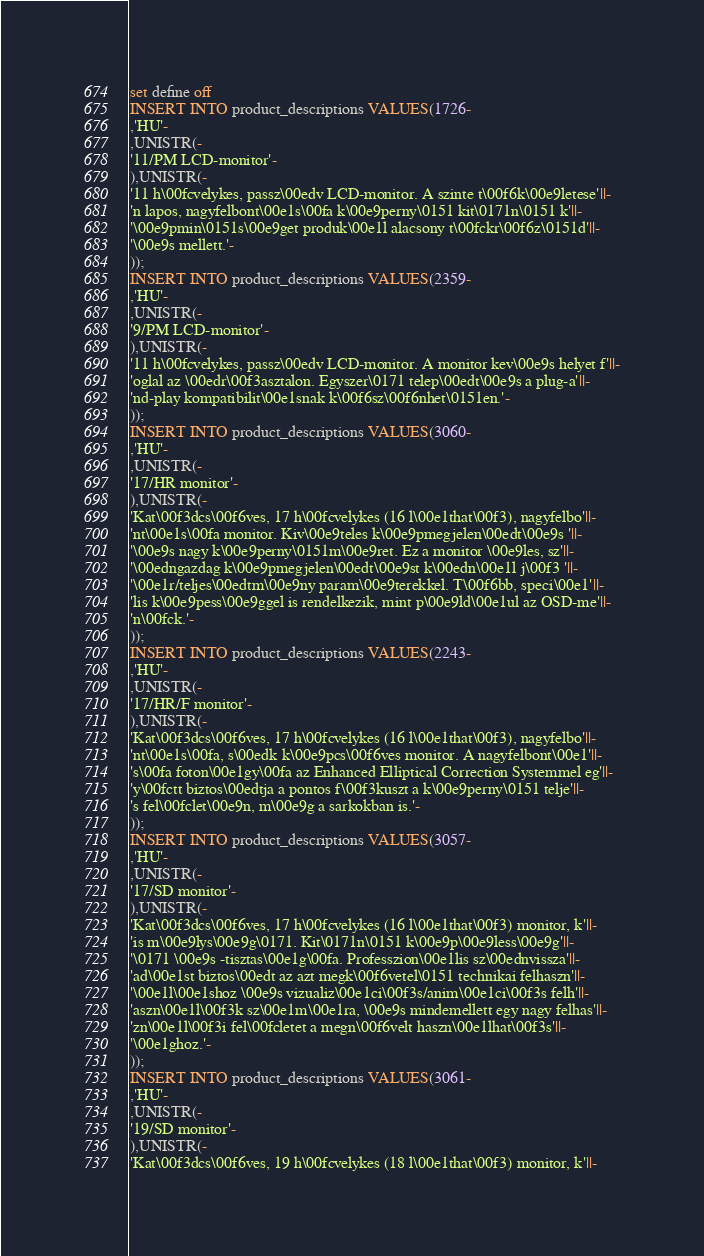<code> <loc_0><loc_0><loc_500><loc_500><_SQL_>set define off
INSERT INTO product_descriptions VALUES(1726-
,'HU'-
,UNISTR(-
'11/PM LCD-monitor'-
),UNISTR(-
'11 h\00fcvelykes, passz\00edv LCD-monitor. A szinte t\00f6k\00e9letese'||-
'n lapos, nagyfelbont\00e1s\00fa k\00e9perny\0151 kit\0171n\0151 k'||-
'\00e9pmin\0151s\00e9get produk\00e1l alacsony t\00fckr\00f6z\0151d'||-
'\00e9s mellett.'-
));
INSERT INTO product_descriptions VALUES(2359-
,'HU'-
,UNISTR(-
'9/PM LCD-monitor'-
),UNISTR(-
'11 h\00fcvelykes, passz\00edv LCD-monitor. A monitor kev\00e9s helyet f'||-
'oglal az \00edr\00f3asztalon. Egyszer\0171 telep\00edt\00e9s a plug-a'||-
'nd-play kompatibilit\00e1snak k\00f6sz\00f6nhet\0151en.'-
));
INSERT INTO product_descriptions VALUES(3060-
,'HU'-
,UNISTR(-
'17/HR monitor'-
),UNISTR(-
'Kat\00f3dcs\00f6ves, 17 h\00fcvelykes (16 l\00e1that\00f3), nagyfelbo'||-
'nt\00e1s\00fa monitor. Kiv\00e9teles k\00e9pmegjelen\00edt\00e9s '||-
'\00e9s nagy k\00e9perny\0151m\00e9ret. Ez a monitor \00e9les, sz'||-
'\00edngazdag k\00e9pmegjelen\00edt\00e9st k\00edn\00e1l j\00f3 '||-
'\00e1r/teljes\00edtm\00e9ny param\00e9terekkel. T\00f6bb, speci\00e1'||-
'lis k\00e9pess\00e9ggel is rendelkezik, mint p\00e9ld\00e1ul az OSD-me'||-
'n\00fck.'-
));
INSERT INTO product_descriptions VALUES(2243-
,'HU'-
,UNISTR(-
'17/HR/F monitor'-
),UNISTR(-
'Kat\00f3dcs\00f6ves, 17 h\00fcvelykes (16 l\00e1that\00f3), nagyfelbo'||-
'nt\00e1s\00fa, s\00edk k\00e9pcs\00f6ves monitor. A nagyfelbont\00e1'||-
's\00fa foton\00e1gy\00fa az Enhanced Elliptical Correction Systemmel eg'||-
'y\00fctt biztos\00edtja a pontos f\00f3kuszt a k\00e9perny\0151 telje'||-
's fel\00fclet\00e9n, m\00e9g a sarkokban is.'-
));
INSERT INTO product_descriptions VALUES(3057-
,'HU'-
,UNISTR(-
'17/SD monitor'-
),UNISTR(-
'Kat\00f3dcs\00f6ves, 17 h\00fcvelykes (16 l\00e1that\00f3) monitor, k'||-
'is m\00e9lys\00e9g\0171. Kit\0171n\0151 k\00e9p\00e9less\00e9g'||-
'\0171 \00e9s -tisztas\00e1g\00fa. Professzion\00e1lis sz\00ednvissza'||-
'ad\00e1st biztos\00edt az azt megk\00f6vetel\0151 technikai felhaszn'||-
'\00e1l\00e1shoz \00e9s vizualiz\00e1ci\00f3s/anim\00e1ci\00f3s felh'||-
'aszn\00e1l\00f3k sz\00e1m\00e1ra, \00e9s mindemellett egy nagy felhas'||-
'zn\00e1l\00f3i fel\00fcletet a megn\00f6velt haszn\00e1lhat\00f3s'||-
'\00e1ghoz.'-
));
INSERT INTO product_descriptions VALUES(3061-
,'HU'-
,UNISTR(-
'19/SD monitor'-
),UNISTR(-
'Kat\00f3dcs\00f6ves, 19 h\00fcvelykes (18 l\00e1that\00f3) monitor, k'||-</code> 